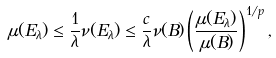<formula> <loc_0><loc_0><loc_500><loc_500>\mu ( E _ { \lambda } ) \leq \frac { 1 } { \lambda } \nu ( E _ { \lambda } ) \leq \frac { c } { \lambda } \nu ( B ) \left ( \frac { \mu ( E _ { \lambda } ) } { \mu ( B ) } \right ) ^ { 1 / p } ,</formula> 